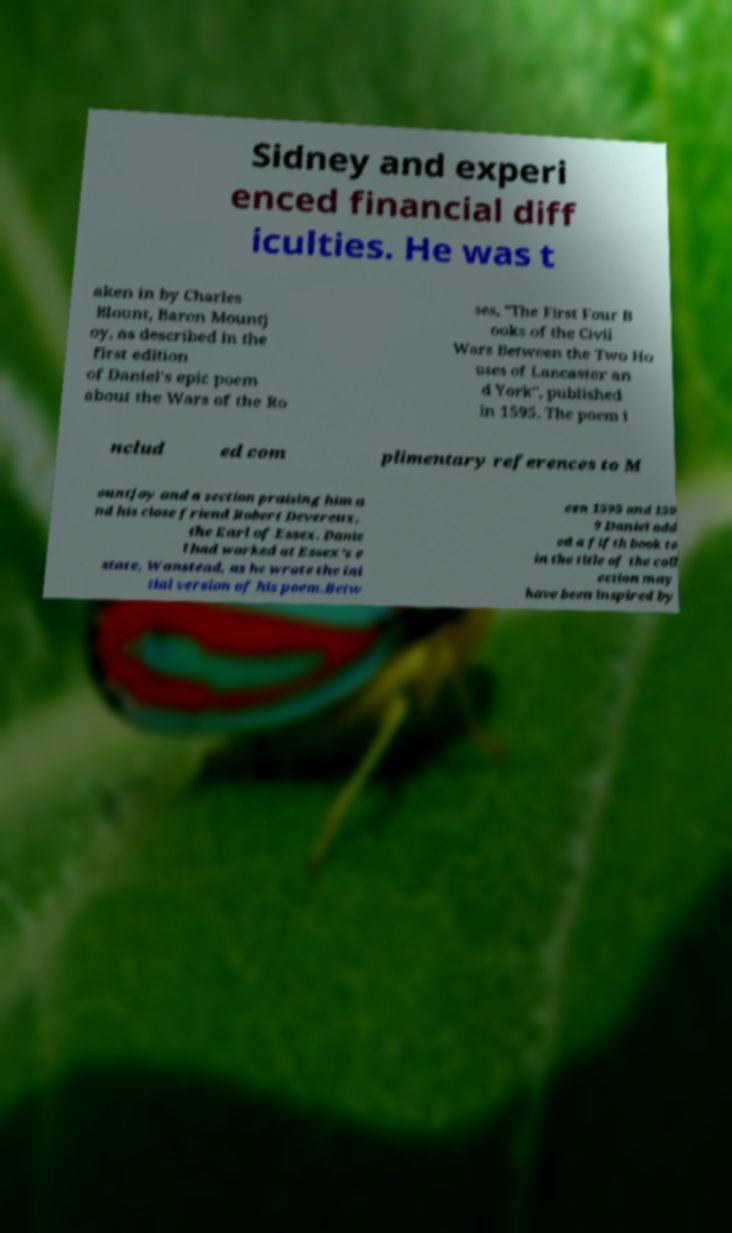What messages or text are displayed in this image? I need them in a readable, typed format. Sidney and experi enced financial diff iculties. He was t aken in by Charles Blount, Baron Mountj oy, as described in the first edition of Daniel's epic poem about the Wars of the Ro ses, "The First Four B ooks of the Civil Wars Between the Two Ho uses of Lancaster an d York", published in 1595. The poem i nclud ed com plimentary references to M ountjoy and a section praising him a nd his close friend Robert Devereux, the Earl of Essex. Danie l had worked at Essex's e state, Wanstead, as he wrote the ini tial version of his poem.Betw een 1595 and 159 9 Daniel add ed a fifth book to in the title of the coll ection may have been inspired by 